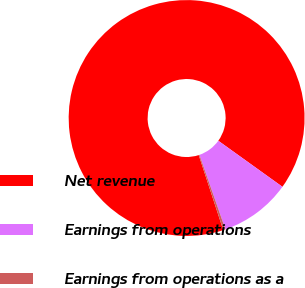Convert chart to OTSL. <chart><loc_0><loc_0><loc_500><loc_500><pie_chart><fcel>Net revenue<fcel>Earnings from operations<fcel>Earnings from operations as a<nl><fcel>89.94%<fcel>9.76%<fcel>0.3%<nl></chart> 